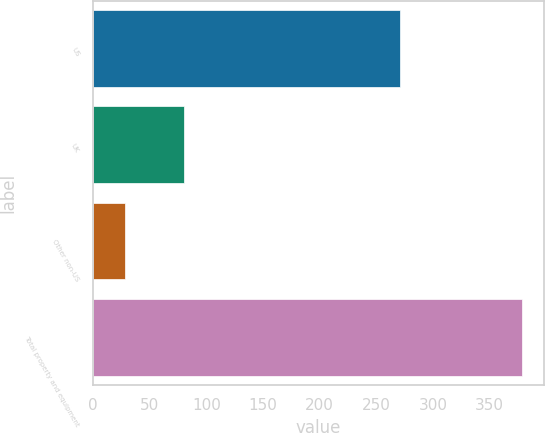Convert chart to OTSL. <chart><loc_0><loc_0><loc_500><loc_500><bar_chart><fcel>US<fcel>UK<fcel>Other non-US<fcel>Total property and equipment<nl><fcel>271<fcel>80<fcel>28<fcel>379<nl></chart> 